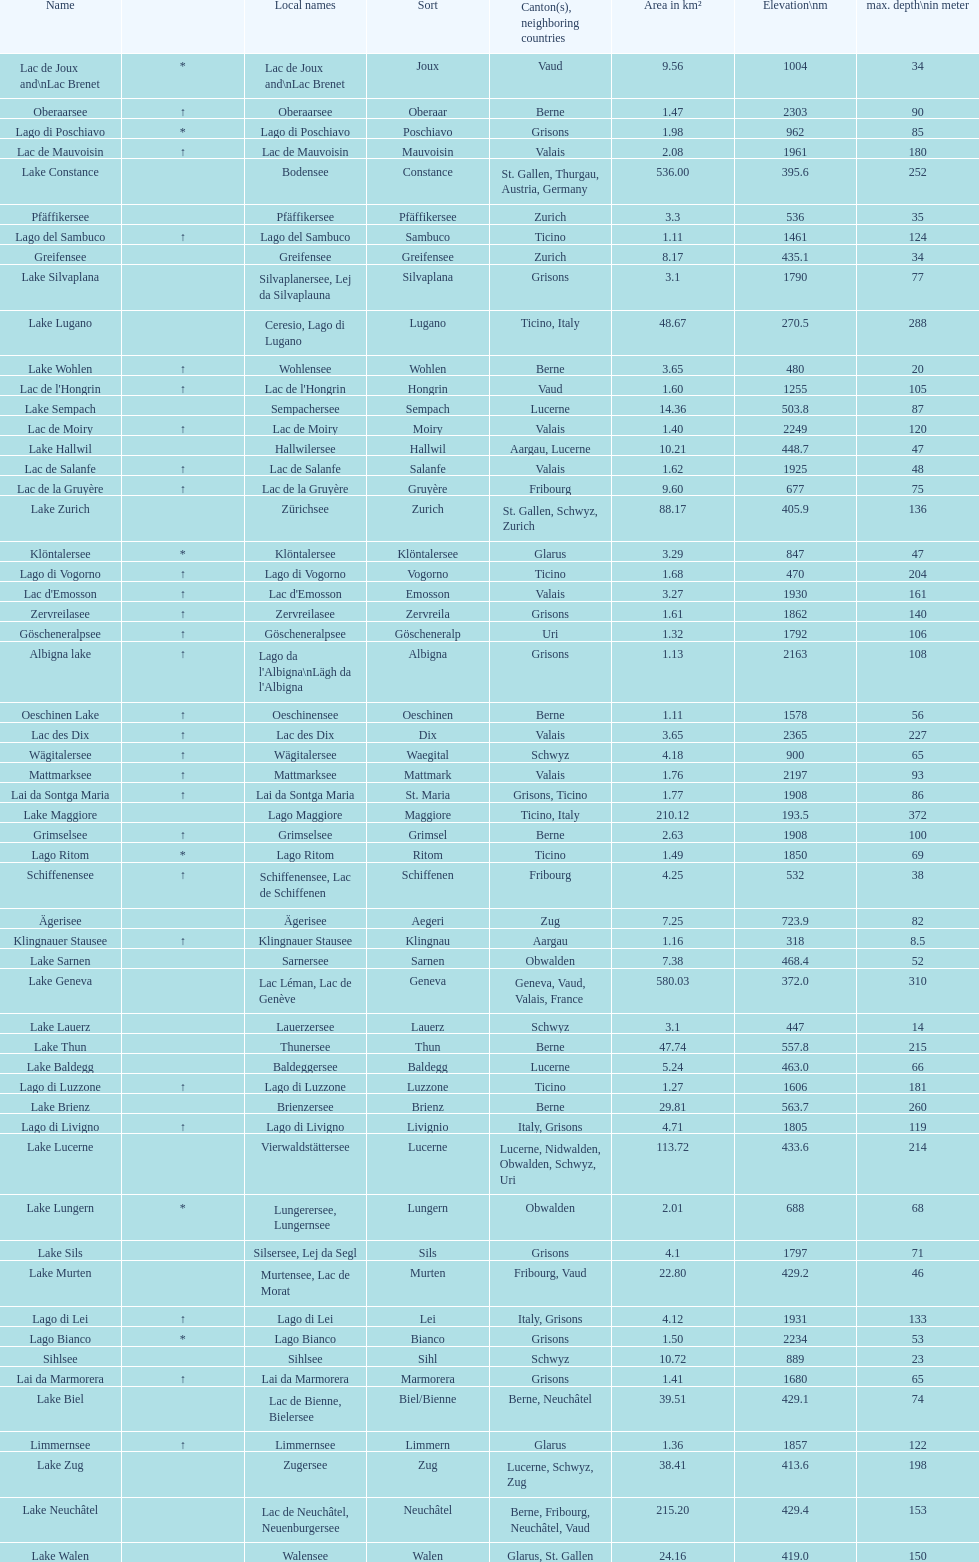What is the number of lakes that have an area less than 100 km squared? 51. 